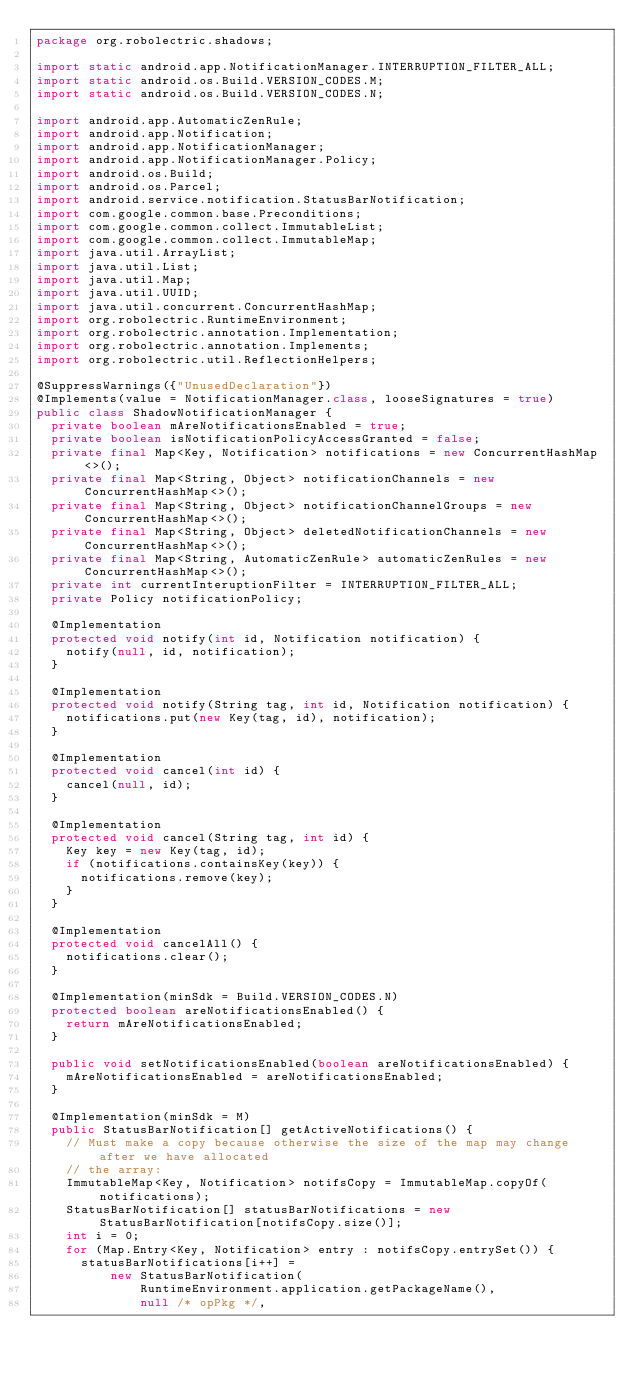Convert code to text. <code><loc_0><loc_0><loc_500><loc_500><_Java_>package org.robolectric.shadows;

import static android.app.NotificationManager.INTERRUPTION_FILTER_ALL;
import static android.os.Build.VERSION_CODES.M;
import static android.os.Build.VERSION_CODES.N;

import android.app.AutomaticZenRule;
import android.app.Notification;
import android.app.NotificationManager;
import android.app.NotificationManager.Policy;
import android.os.Build;
import android.os.Parcel;
import android.service.notification.StatusBarNotification;
import com.google.common.base.Preconditions;
import com.google.common.collect.ImmutableList;
import com.google.common.collect.ImmutableMap;
import java.util.ArrayList;
import java.util.List;
import java.util.Map;
import java.util.UUID;
import java.util.concurrent.ConcurrentHashMap;
import org.robolectric.RuntimeEnvironment;
import org.robolectric.annotation.Implementation;
import org.robolectric.annotation.Implements;
import org.robolectric.util.ReflectionHelpers;

@SuppressWarnings({"UnusedDeclaration"})
@Implements(value = NotificationManager.class, looseSignatures = true)
public class ShadowNotificationManager {
  private boolean mAreNotificationsEnabled = true;
  private boolean isNotificationPolicyAccessGranted = false;
  private final Map<Key, Notification> notifications = new ConcurrentHashMap<>();
  private final Map<String, Object> notificationChannels = new ConcurrentHashMap<>();
  private final Map<String, Object> notificationChannelGroups = new ConcurrentHashMap<>();
  private final Map<String, Object> deletedNotificationChannels = new ConcurrentHashMap<>();
  private final Map<String, AutomaticZenRule> automaticZenRules = new ConcurrentHashMap<>();
  private int currentInteruptionFilter = INTERRUPTION_FILTER_ALL;
  private Policy notificationPolicy;

  @Implementation
  protected void notify(int id, Notification notification) {
    notify(null, id, notification);
  }

  @Implementation
  protected void notify(String tag, int id, Notification notification) {
    notifications.put(new Key(tag, id), notification);
  }

  @Implementation
  protected void cancel(int id) {
    cancel(null, id);
  }

  @Implementation
  protected void cancel(String tag, int id) {
    Key key = new Key(tag, id);
    if (notifications.containsKey(key)) {
      notifications.remove(key);
    }
  }

  @Implementation
  protected void cancelAll() {
    notifications.clear();
  }

  @Implementation(minSdk = Build.VERSION_CODES.N)
  protected boolean areNotificationsEnabled() {
    return mAreNotificationsEnabled;
  }

  public void setNotificationsEnabled(boolean areNotificationsEnabled) {
    mAreNotificationsEnabled = areNotificationsEnabled;
  }

  @Implementation(minSdk = M)
  public StatusBarNotification[] getActiveNotifications() {
    // Must make a copy because otherwise the size of the map may change after we have allocated
    // the array:
    ImmutableMap<Key, Notification> notifsCopy = ImmutableMap.copyOf(notifications);
    StatusBarNotification[] statusBarNotifications = new StatusBarNotification[notifsCopy.size()];
    int i = 0;
    for (Map.Entry<Key, Notification> entry : notifsCopy.entrySet()) {
      statusBarNotifications[i++] =
          new StatusBarNotification(
              RuntimeEnvironment.application.getPackageName(),
              null /* opPkg */,</code> 